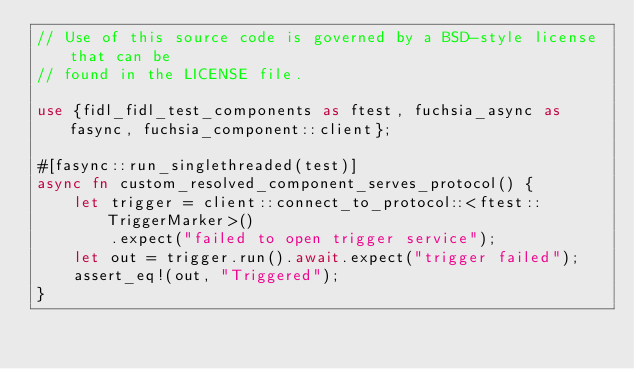<code> <loc_0><loc_0><loc_500><loc_500><_Rust_>// Use of this source code is governed by a BSD-style license that can be
// found in the LICENSE file.

use {fidl_fidl_test_components as ftest, fuchsia_async as fasync, fuchsia_component::client};

#[fasync::run_singlethreaded(test)]
async fn custom_resolved_component_serves_protocol() {
    let trigger = client::connect_to_protocol::<ftest::TriggerMarker>()
        .expect("failed to open trigger service");
    let out = trigger.run().await.expect("trigger failed");
    assert_eq!(out, "Triggered");
}
</code> 